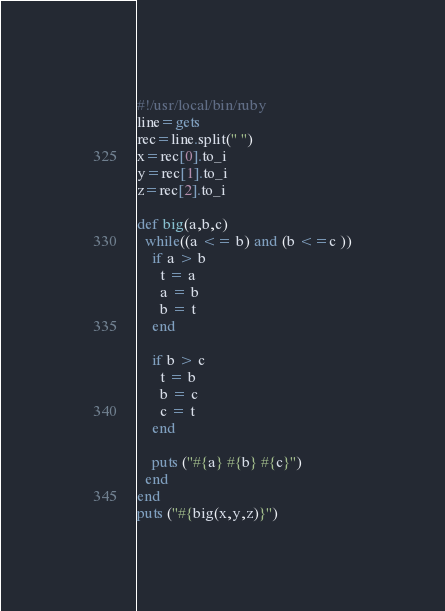Convert code to text. <code><loc_0><loc_0><loc_500><loc_500><_Ruby_>#!/usr/local/bin/ruby
line=gets
rec=line.split(" ")
x=rec[0].to_i 
y=rec[1].to_i
z=rec[2].to_i

def big(a,b,c)
  while((a <= b) and (b <=c ))
    if a > b
      t = a
      a = b
      b = t
    end
    
    if b > c
      t = b
      b = c 
      c = t
    end
    
    puts ("#{a} #{b} #{c}")
  end
end
puts ("#{big(x,y,z)}")</code> 